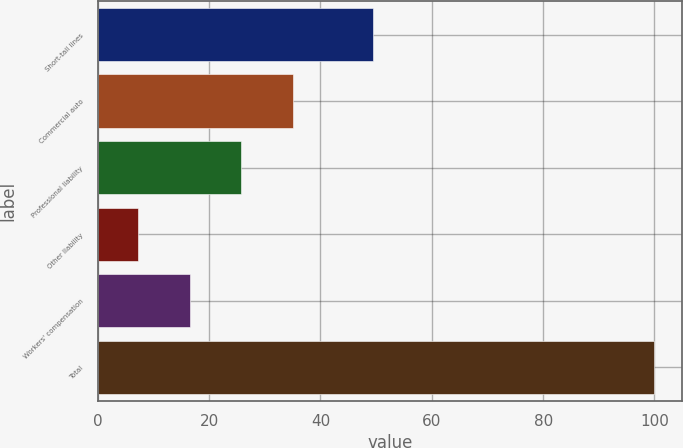Convert chart. <chart><loc_0><loc_0><loc_500><loc_500><bar_chart><fcel>Short-tail lines<fcel>Commercial auto<fcel>Professional liability<fcel>Other liability<fcel>Workers' compensation<fcel>Total<nl><fcel>49.4<fcel>35.04<fcel>25.76<fcel>7.2<fcel>16.48<fcel>100<nl></chart> 